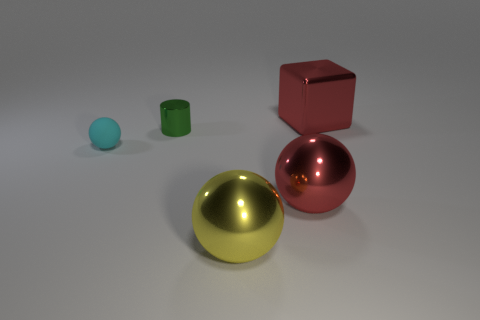There is a green metal object; what number of tiny cyan spheres are behind it?
Provide a short and direct response. 0. How many large red shiny objects are both to the right of the large red metal sphere and in front of the big block?
Provide a short and direct response. 0. What is the shape of the yellow object that is the same material as the small green thing?
Offer a very short reply. Sphere. There is a red metal object that is behind the small rubber thing; does it have the same size as the red ball that is on the right side of the small green cylinder?
Offer a terse response. Yes. There is a tiny thing on the right side of the matte sphere; what color is it?
Your answer should be very brief. Green. The ball that is to the left of the ball in front of the red metal sphere is made of what material?
Make the answer very short. Rubber. There is a yellow metallic object; what shape is it?
Your response must be concise. Sphere. What is the material of the red thing that is the same shape as the small cyan object?
Your response must be concise. Metal. What number of green shiny objects have the same size as the matte ball?
Ensure brevity in your answer.  1. There is a red object that is in front of the tiny rubber sphere; is there a large red cube that is left of it?
Offer a very short reply. No. 